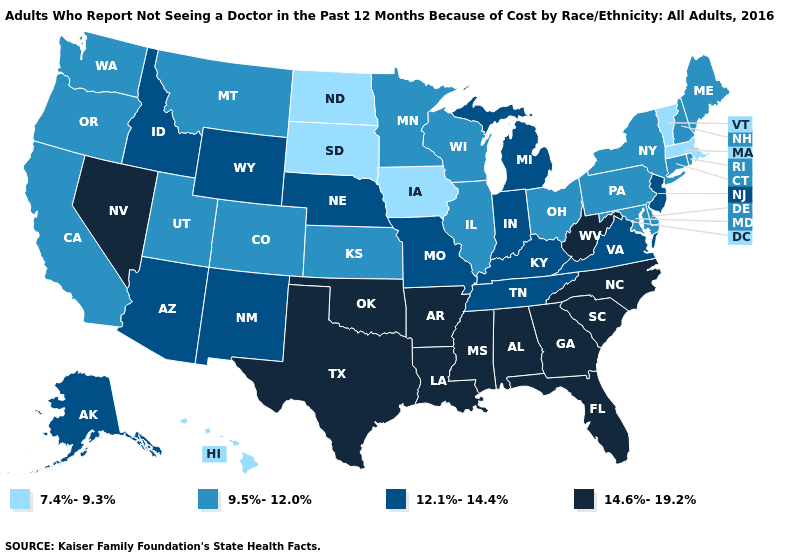Among the states that border Connecticut , which have the lowest value?
Quick response, please. Massachusetts. Name the states that have a value in the range 14.6%-19.2%?
Keep it brief. Alabama, Arkansas, Florida, Georgia, Louisiana, Mississippi, Nevada, North Carolina, Oklahoma, South Carolina, Texas, West Virginia. What is the lowest value in the West?
Give a very brief answer. 7.4%-9.3%. Does North Dakota have the lowest value in the USA?
Quick response, please. Yes. Name the states that have a value in the range 7.4%-9.3%?
Keep it brief. Hawaii, Iowa, Massachusetts, North Dakota, South Dakota, Vermont. What is the highest value in the USA?
Keep it brief. 14.6%-19.2%. What is the value of Montana?
Concise answer only. 9.5%-12.0%. Which states hav the highest value in the West?
Concise answer only. Nevada. Which states have the highest value in the USA?
Keep it brief. Alabama, Arkansas, Florida, Georgia, Louisiana, Mississippi, Nevada, North Carolina, Oklahoma, South Carolina, Texas, West Virginia. What is the lowest value in the MidWest?
Answer briefly. 7.4%-9.3%. What is the lowest value in the Northeast?
Keep it brief. 7.4%-9.3%. Name the states that have a value in the range 12.1%-14.4%?
Answer briefly. Alaska, Arizona, Idaho, Indiana, Kentucky, Michigan, Missouri, Nebraska, New Jersey, New Mexico, Tennessee, Virginia, Wyoming. What is the value of Wyoming?
Keep it brief. 12.1%-14.4%. Name the states that have a value in the range 12.1%-14.4%?
Answer briefly. Alaska, Arizona, Idaho, Indiana, Kentucky, Michigan, Missouri, Nebraska, New Jersey, New Mexico, Tennessee, Virginia, Wyoming. Is the legend a continuous bar?
Write a very short answer. No. 